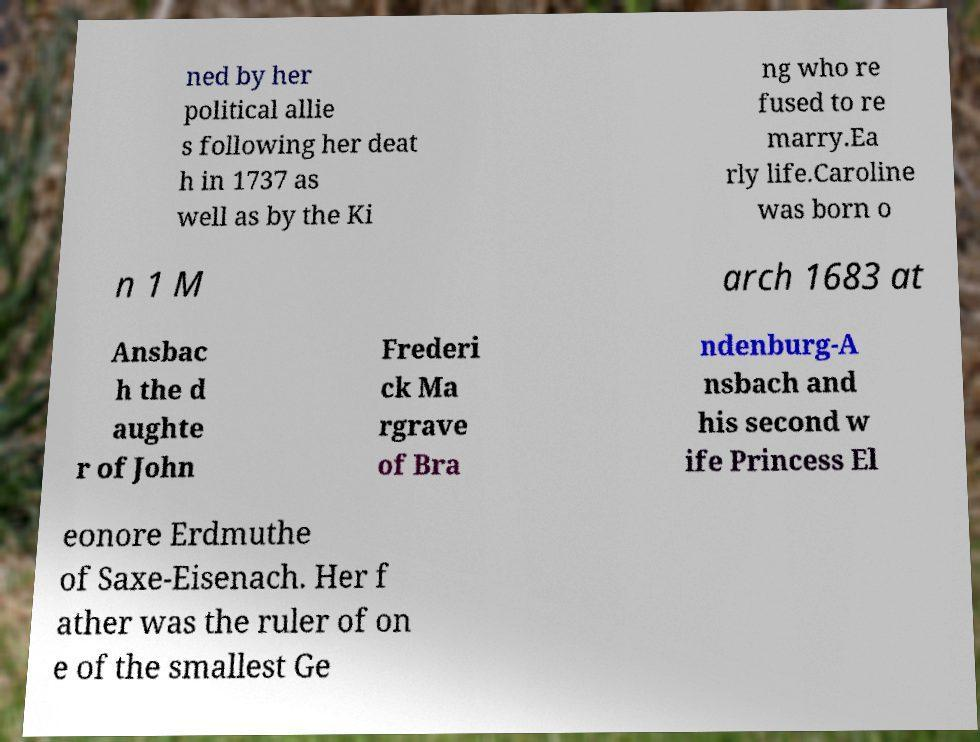Can you accurately transcribe the text from the provided image for me? ned by her political allie s following her deat h in 1737 as well as by the Ki ng who re fused to re marry.Ea rly life.Caroline was born o n 1 M arch 1683 at Ansbac h the d aughte r of John Frederi ck Ma rgrave of Bra ndenburg-A nsbach and his second w ife Princess El eonore Erdmuthe of Saxe-Eisenach. Her f ather was the ruler of on e of the smallest Ge 